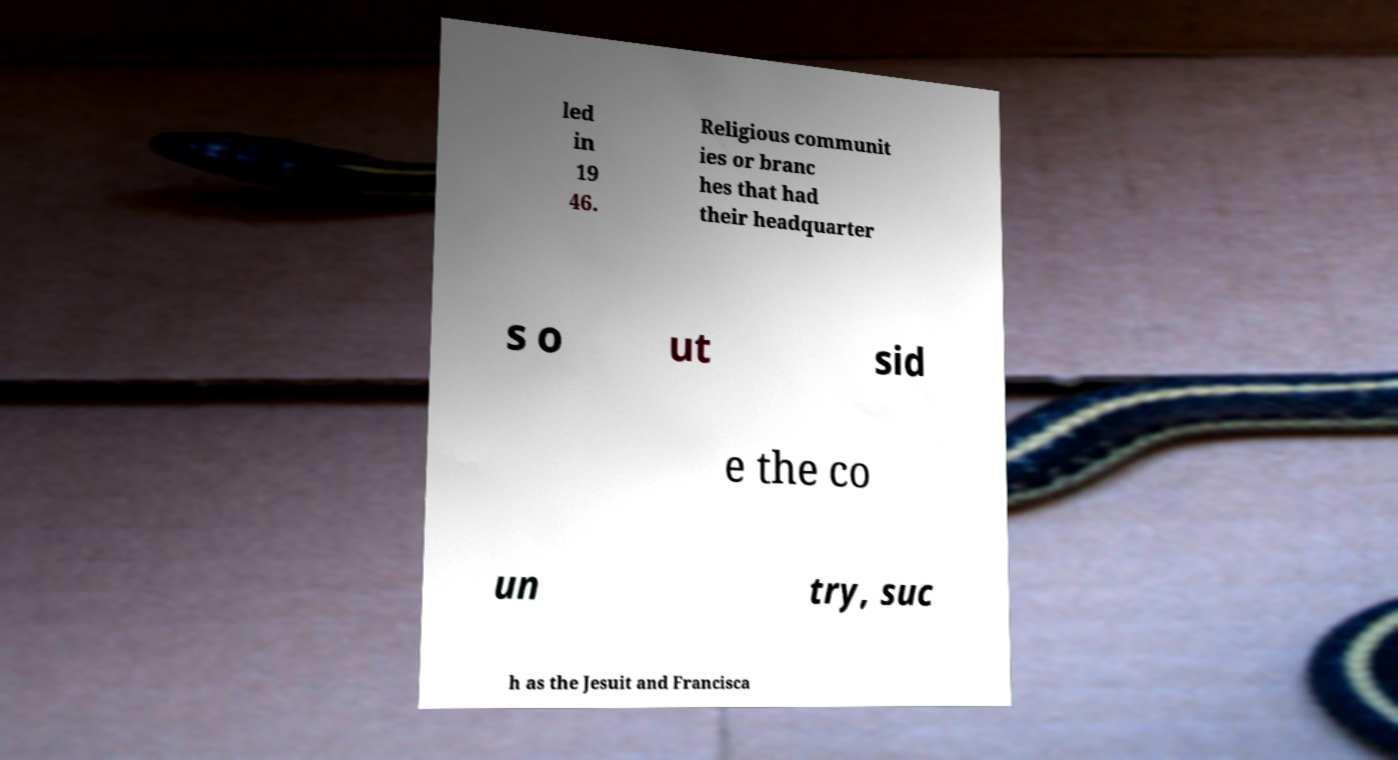Can you accurately transcribe the text from the provided image for me? led in 19 46. Religious communit ies or branc hes that had their headquarter s o ut sid e the co un try, suc h as the Jesuit and Francisca 